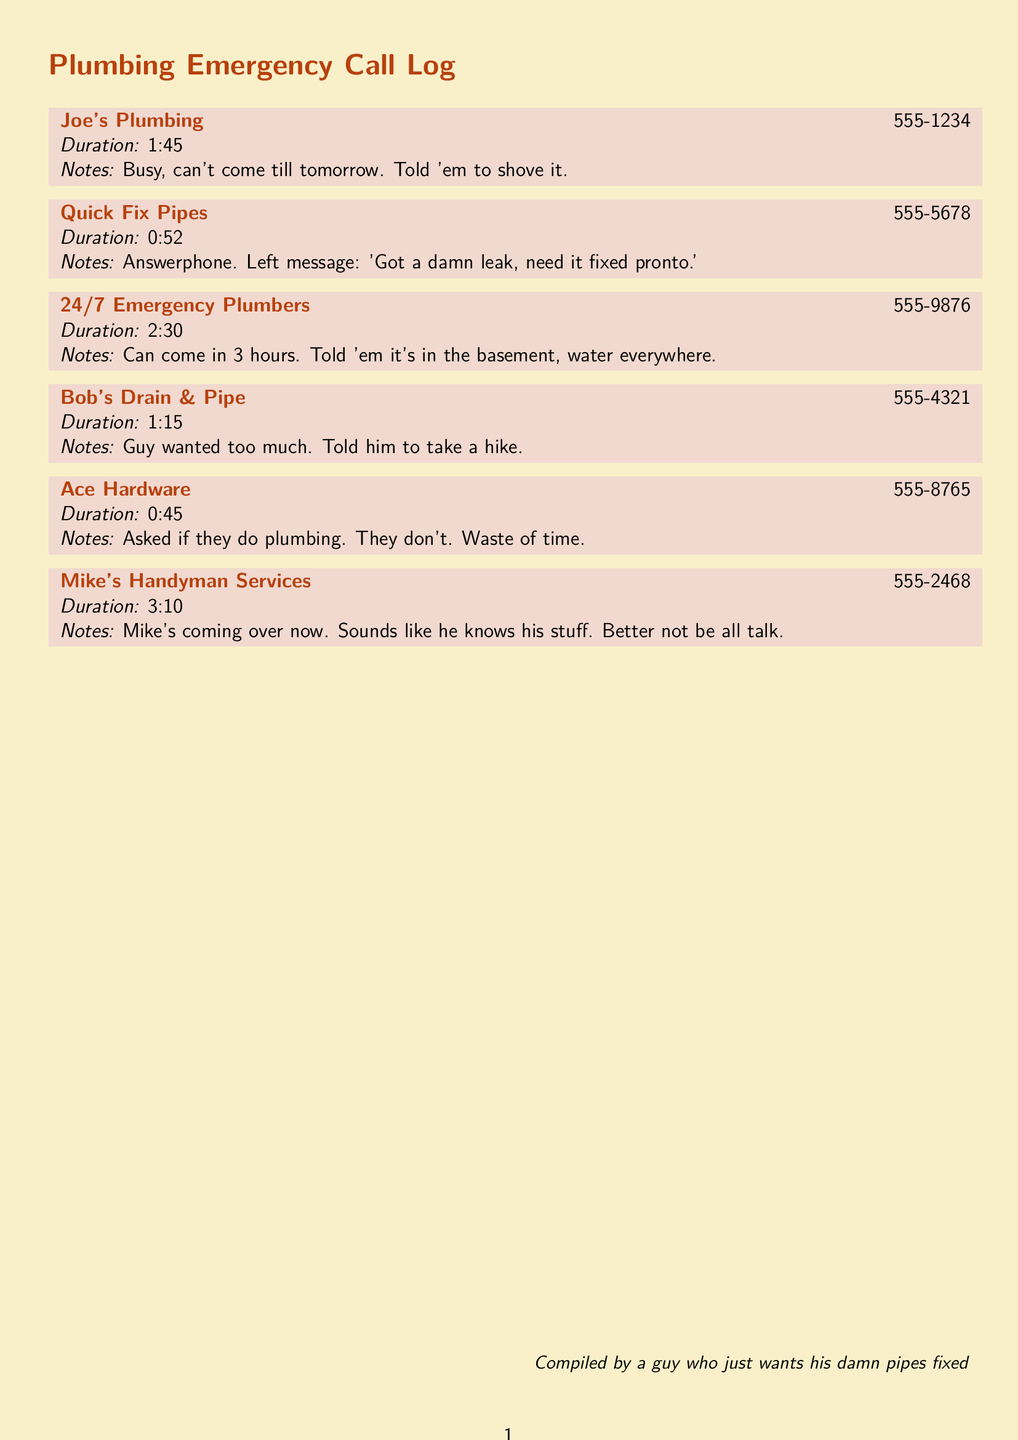What was the first plumber called? The first plumber called was Joe's Plumbing, as noted at the top of the log.
Answer: Joe's Plumbing How long was the call to Mike's Handyman Services? The duration of the call to Mike's Handyman Services is recorded as 3:10.
Answer: 3:10 Which plumber was available to come in 3 hours? The plumber who could come in 3 hours is noted clearly in the log.
Answer: 24/7 Emergency Plumbers How many calls were answered by answering machines? There was one call answered by an answering machine as noted in the records.
Answer: 1 What did the caller say to Bob's Drain & Pipe? The response to Bob's Drain & Pipe is documented in the notes section.
Answer: Told him to take a hike Who is coming over to fix the leak? The individual mentioned explicitly as coming over to fix the leak is logged in the document.
Answer: Mike 